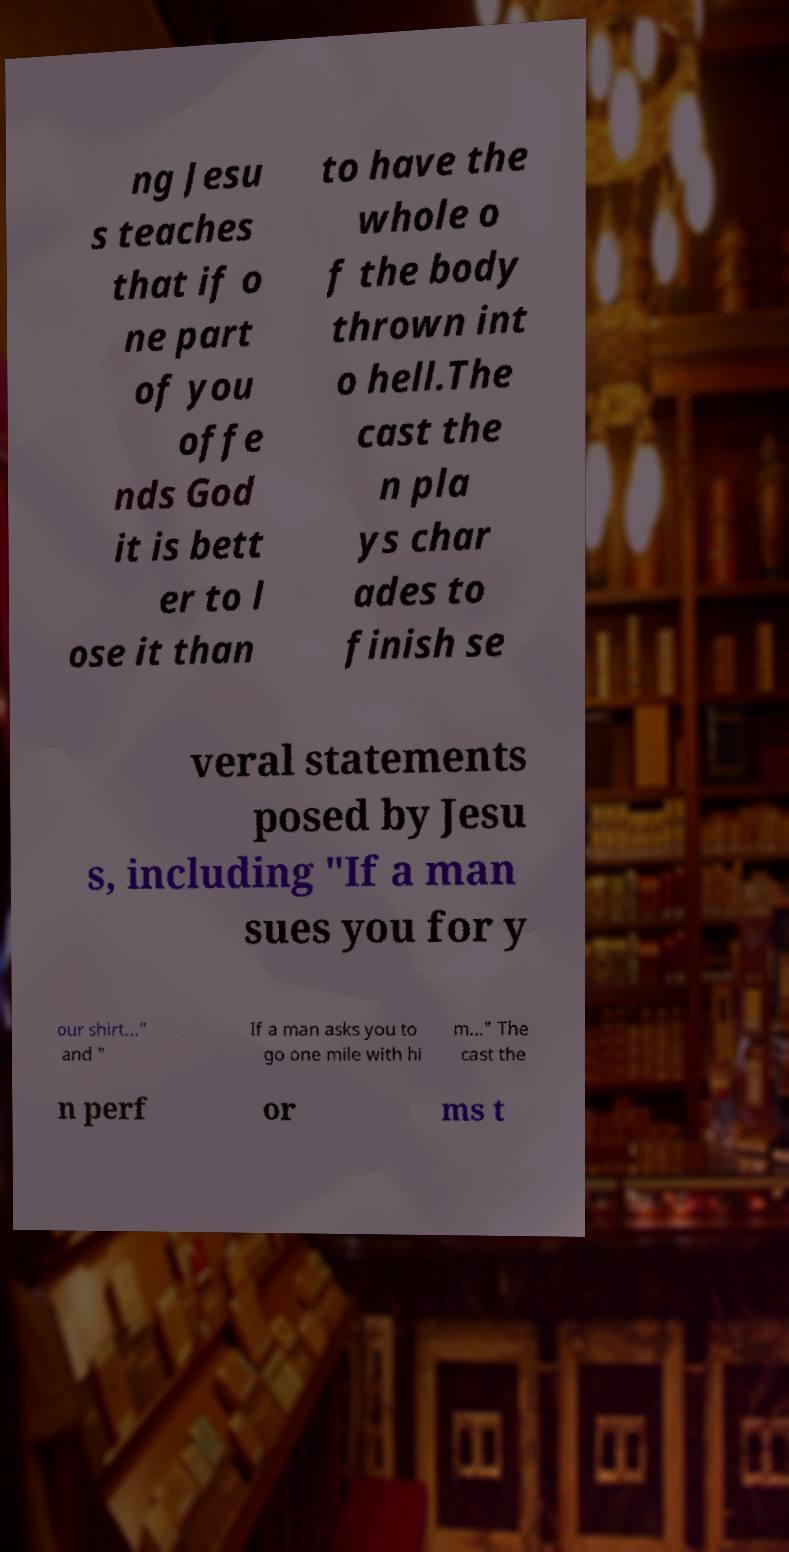What messages or text are displayed in this image? I need them in a readable, typed format. ng Jesu s teaches that if o ne part of you offe nds God it is bett er to l ose it than to have the whole o f the body thrown int o hell.The cast the n pla ys char ades to finish se veral statements posed by Jesu s, including "If a man sues you for y our shirt..." and " If a man asks you to go one mile with hi m..." The cast the n perf or ms t 